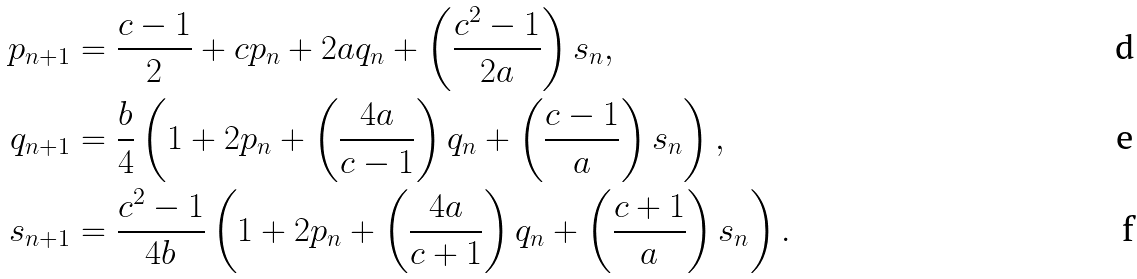<formula> <loc_0><loc_0><loc_500><loc_500>p _ { n + 1 } & = \frac { c - 1 } { 2 } + c p _ { n } + 2 a q _ { n } + \left ( \frac { c ^ { 2 } - 1 } { 2 a } \right ) s _ { n } , \\ q _ { n + 1 } & = \frac { b } { 4 } \left ( 1 + 2 p _ { n } + \left ( \frac { 4 a } { c - 1 } \right ) q _ { n } + \left ( \frac { c - 1 } { a } \right ) s _ { n } \right ) , \\ s _ { n + 1 } & = \frac { c ^ { 2 } - 1 } { 4 b } \left ( 1 + 2 p _ { n } + \left ( \frac { 4 a } { c + 1 } \right ) q _ { n } + \left ( \frac { c + 1 } { a } \right ) s _ { n } \right ) .</formula> 